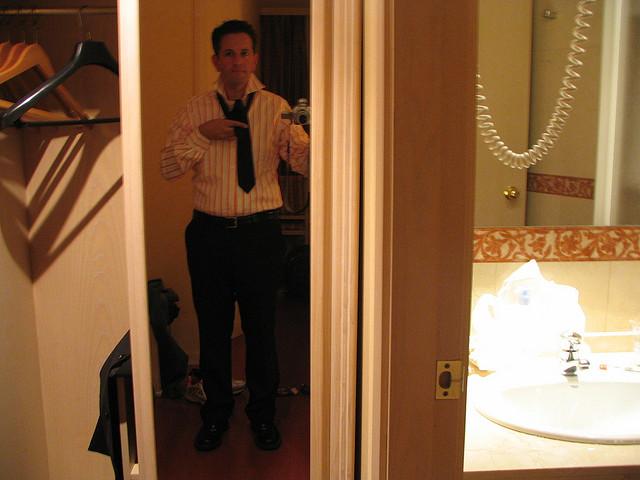Is there a cord nearby?
Give a very brief answer. Yes. Who is the person in the picture photography?
Write a very short answer. Man. What room is the person standing in?
Keep it brief. Bathroom. Is this a bathroom?
Give a very brief answer. Yes. What is this man holding in his hands?
Be succinct. Camera. 